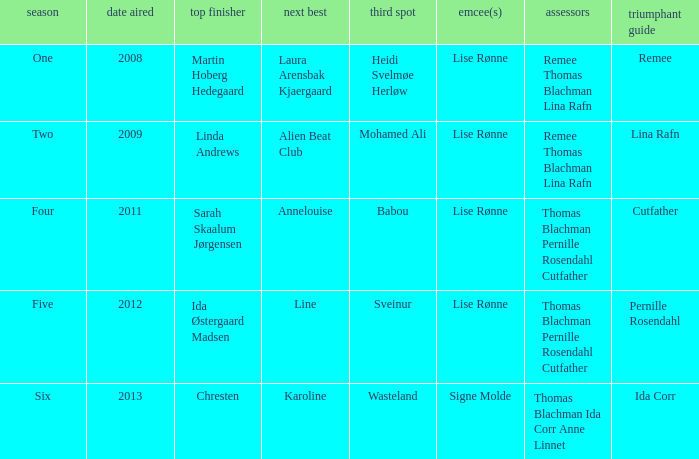Who was the second-place finisher in season five? Line. 